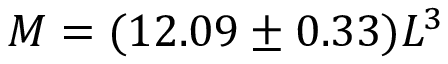<formula> <loc_0><loc_0><loc_500><loc_500>M = ( 1 2 . 0 9 \pm 0 . 3 3 ) L ^ { 3 }</formula> 